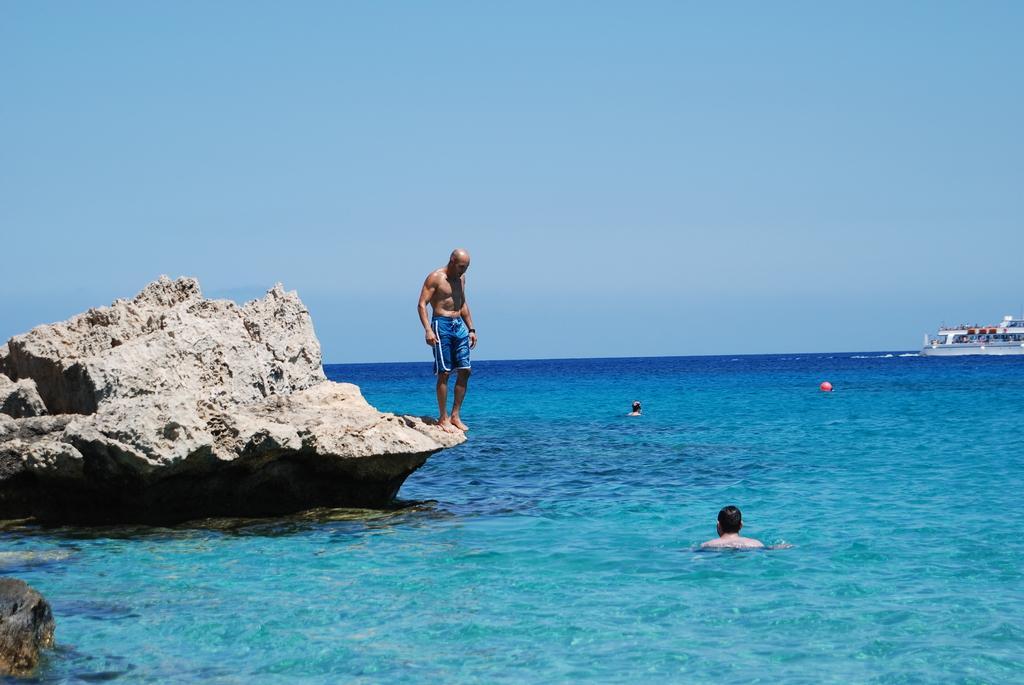Describe this image in one or two sentences. In this image there is the sky, there is a sea, there is rock truncated towards the left of the image, there is a person on the rock, there are persons in the sea, there is a ball in the sea, there is a ship truncated towards the right of the image. 